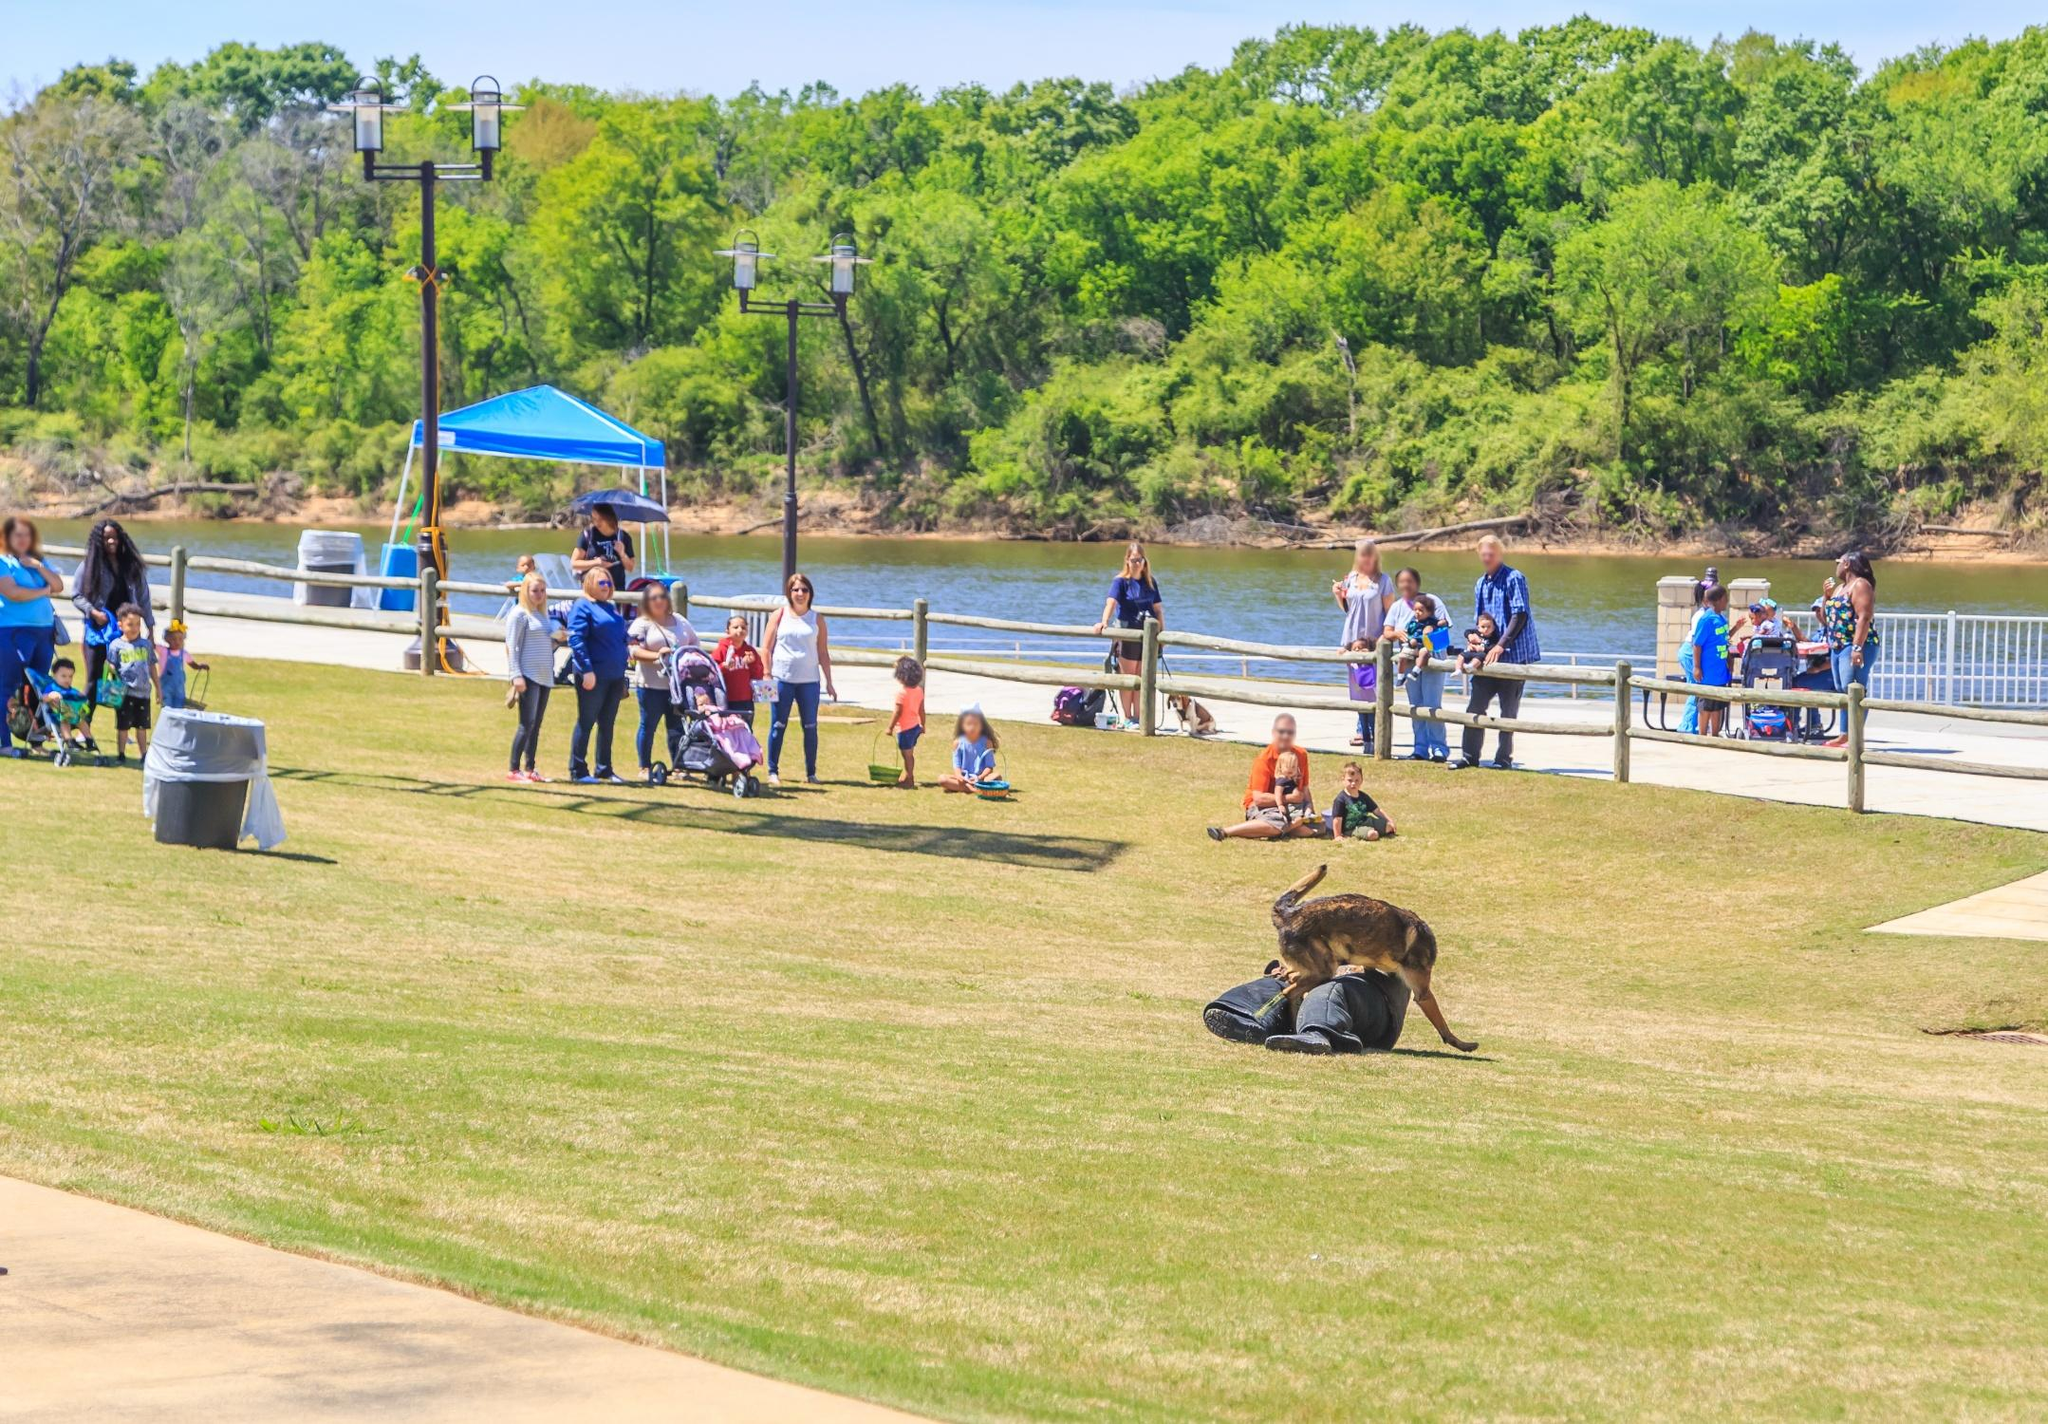What activities can you infer people are engaging in at the park? In this image, people are engaging in a variety of relaxing and recreational activities. Some are walking along the riverside path, possibly enjoying the view and fresh air. Others are seated on the grass, seemingly in conversation or watching their children play. There are also individuals who appear to be taking care of pets, and children who are either running around or being pushed in strollers. Overall, it’s a scene full of leisure and enjoyment. 